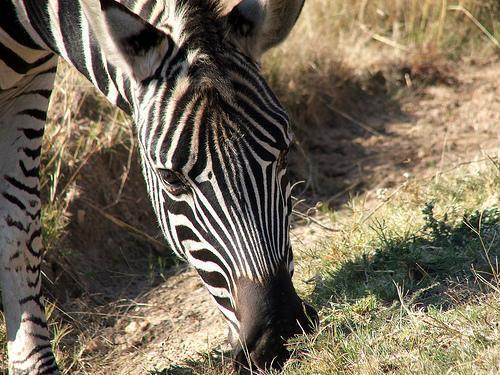How many zebra are there?
Give a very brief answer. 1. 